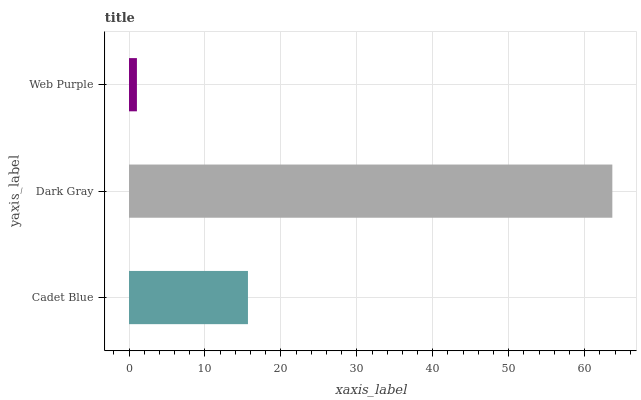Is Web Purple the minimum?
Answer yes or no. Yes. Is Dark Gray the maximum?
Answer yes or no. Yes. Is Dark Gray the minimum?
Answer yes or no. No. Is Web Purple the maximum?
Answer yes or no. No. Is Dark Gray greater than Web Purple?
Answer yes or no. Yes. Is Web Purple less than Dark Gray?
Answer yes or no. Yes. Is Web Purple greater than Dark Gray?
Answer yes or no. No. Is Dark Gray less than Web Purple?
Answer yes or no. No. Is Cadet Blue the high median?
Answer yes or no. Yes. Is Cadet Blue the low median?
Answer yes or no. Yes. Is Dark Gray the high median?
Answer yes or no. No. Is Web Purple the low median?
Answer yes or no. No. 